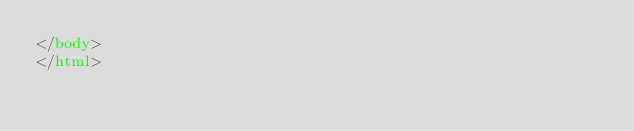Convert code to text. <code><loc_0><loc_0><loc_500><loc_500><_HTML_></body>
</html></code> 